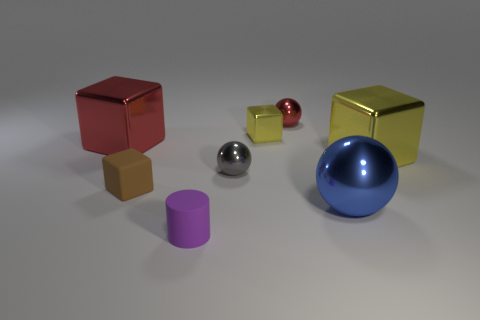Subtract all yellow blocks. How many were subtracted if there are1yellow blocks left? 1 Add 2 large yellow metal cubes. How many objects exist? 10 Subtract all balls. How many objects are left? 5 Subtract 0 purple spheres. How many objects are left? 8 Subtract all big yellow metallic balls. Subtract all small purple matte things. How many objects are left? 7 Add 4 yellow cubes. How many yellow cubes are left? 6 Add 8 brown blocks. How many brown blocks exist? 9 